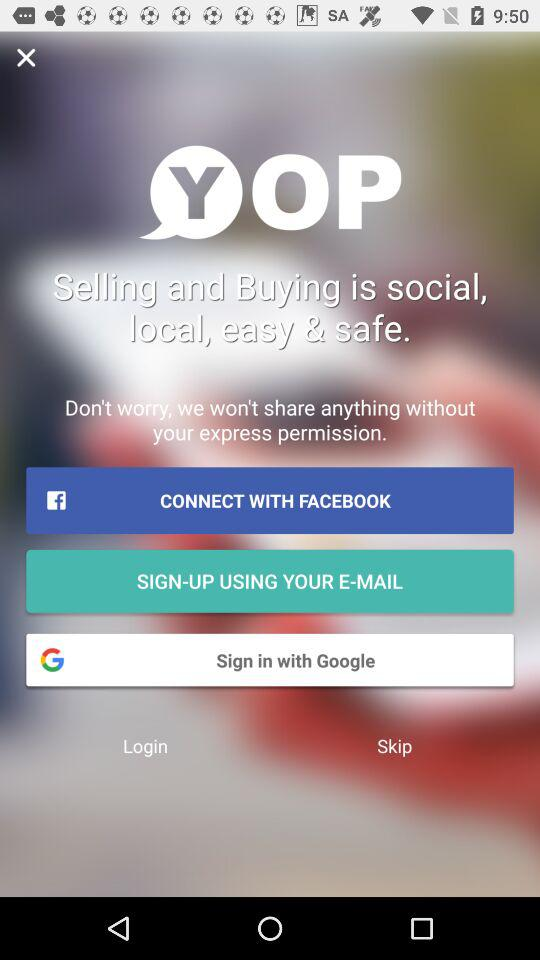Through which application can it be signed in? You can sign in through "GOOGLE". 